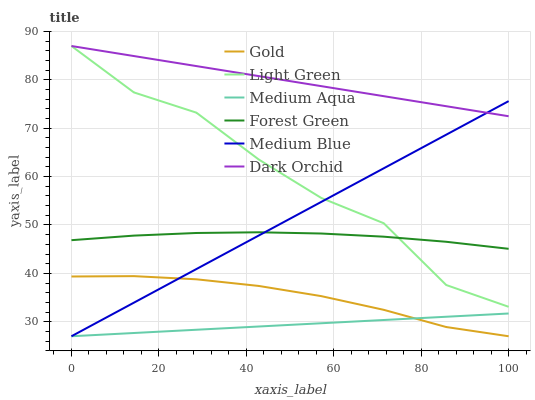Does Medium Aqua have the minimum area under the curve?
Answer yes or no. Yes. Does Dark Orchid have the maximum area under the curve?
Answer yes or no. Yes. Does Medium Blue have the minimum area under the curve?
Answer yes or no. No. Does Medium Blue have the maximum area under the curve?
Answer yes or no. No. Is Medium Aqua the smoothest?
Answer yes or no. Yes. Is Light Green the roughest?
Answer yes or no. Yes. Is Medium Blue the smoothest?
Answer yes or no. No. Is Medium Blue the roughest?
Answer yes or no. No. Does Gold have the lowest value?
Answer yes or no. Yes. Does Dark Orchid have the lowest value?
Answer yes or no. No. Does Light Green have the highest value?
Answer yes or no. Yes. Does Medium Blue have the highest value?
Answer yes or no. No. Is Medium Aqua less than Forest Green?
Answer yes or no. Yes. Is Light Green greater than Medium Aqua?
Answer yes or no. Yes. Does Dark Orchid intersect Medium Blue?
Answer yes or no. Yes. Is Dark Orchid less than Medium Blue?
Answer yes or no. No. Is Dark Orchid greater than Medium Blue?
Answer yes or no. No. Does Medium Aqua intersect Forest Green?
Answer yes or no. No. 